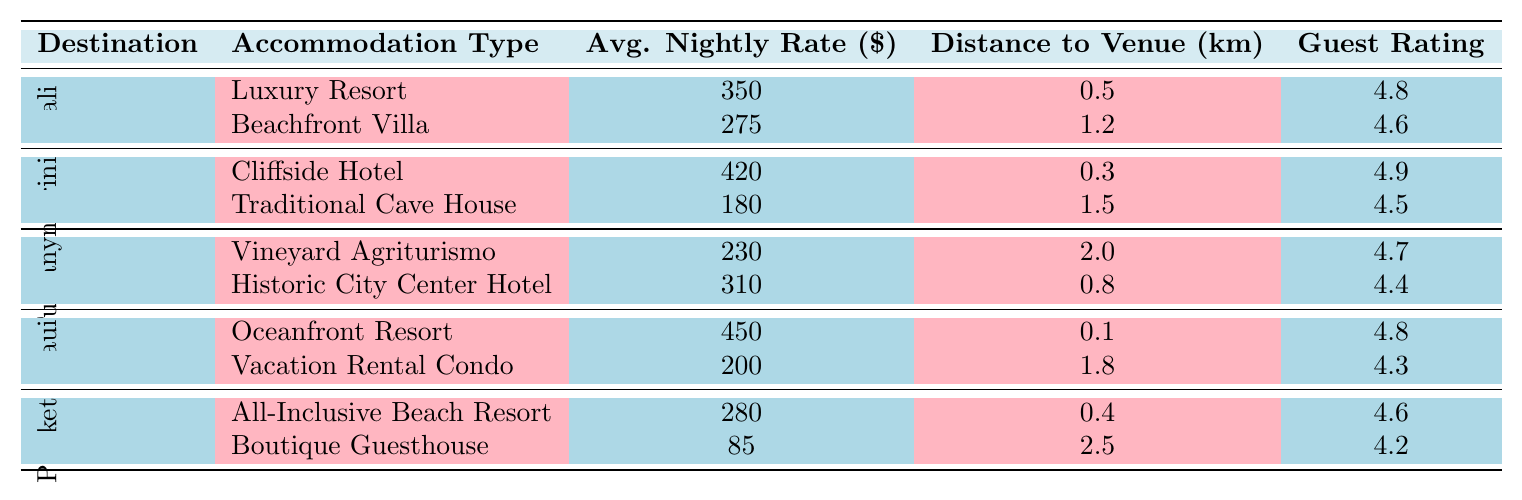What is the average nightly rate for accommodations in Santorini, Greece? The average nightly rates for accommodations in Santorini are $420 for the Cliffside Hotel and $180 for the Traditional Cave House. To find the average, add these two rates: 420 + 180 = 600. Then divide by 2: 600 / 2 = 300.
Answer: 300 Which accommodation in Bali has the highest guest rating? In Bali, the Luxury Resort has a guest rating of 4.8, while the Beachfront Villa has a rating of 4.6. Since 4.8 is higher than 4.6, the Luxury Resort has the highest guest rating.
Answer: Luxury Resort Is the distance to the wedding venue shorter for accommodations in Phuket or Tuscany? The distances to the wedding venues are 0.4 km for the All-Inclusive Beach Resort and 0.3 km for the Boutique Guesthouse in Phuket, and 2.0 km for the Vineyard Agriturismo and 0.8 km for the Historic City Center Hotel in Tuscany. The shortest distance is 0.3 km in Phuket, making it shorter than the shortest in Tuscany, which is 0.8 km.
Answer: Phuket What is the total average nightly rate for all accommodations in Maui? In Maui, the Oceanfront Resort has a rate of $450 and the Vacation Rental Condo is $200. Adding these rates gives 450 + 200 = 650. To find the total average, divide by 2: 650 / 2 = 325.
Answer: 325 How does the guest rating of the Luxury Resort in Maui compare to that of the Historic City Center Hotel in Tuscany? The guest rating for the Luxury Resort in Maui is 4.8, while the rating for the Historic City Center Hotel in Tuscany is 4.4. Since 4.8 is greater than 4.4, the Luxury Resort has a higher guest rating than the Historic City Center Hotel.
Answer: Higher What is the difference in distance to the wedding venue between the Cliffside Hotel in Santorini and the Beachfront Villa in Bali? The distance to the wedding venue for the Cliffside Hotel is 0.3 km and for the Beachfront Villa, it is 1.2 km. The difference is calculated as 1.2 - 0.3 = 0.9 km.
Answer: 0.9 km Which destination has the least expensive accommodation type according to the table? The Boutique Guesthouse in Phuket is listed at $85, which is lower than any other accommodation. Thus, it is the least expensive accommodation type according to the table.
Answer: Phuket How many accommodation types in Tuscany have an average nightly rate above $250? In Tuscany, the Historic City Center Hotel has an average nightly rate of $310, and the Vineyard Agriturismo has a rate of $230. Only the Historic City Center Hotel exceeds $250, so there is 1 accommodation type over $250.
Answer: 1 Is there any accommodation in Bali priced above $300? The Luxury Resort in Bali is priced at $350, which is above $300. Therefore, there is at least one accommodation in Bali priced above $300.
Answer: Yes Which destination has the highest average nightly rate for accommodations? The average nightly rates are $450 for the Oceanfront Resort in Maui, $420 for the Cliffside Hotel in Santorini, and $350 for the Luxury Resort in Bali. Since $450 is the highest rate, Maui has the highest average nightly rate.
Answer: Maui 